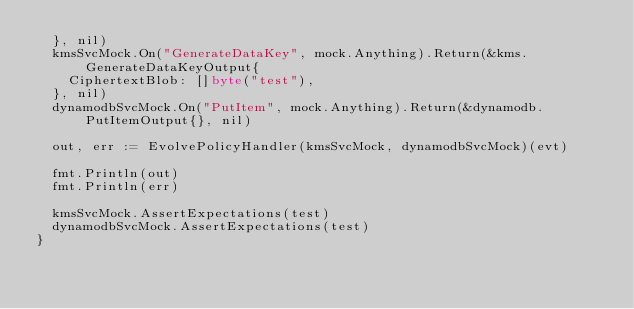Convert code to text. <code><loc_0><loc_0><loc_500><loc_500><_Go_>	}, nil)
	kmsSvcMock.On("GenerateDataKey", mock.Anything).Return(&kms.GenerateDataKeyOutput{
		CiphertextBlob: []byte("test"),
	}, nil)
	dynamodbSvcMock.On("PutItem", mock.Anything).Return(&dynamodb.PutItemOutput{}, nil)

	out, err := EvolvePolicyHandler(kmsSvcMock, dynamodbSvcMock)(evt)

	fmt.Println(out)
	fmt.Println(err)

	kmsSvcMock.AssertExpectations(test)
	dynamodbSvcMock.AssertExpectations(test)
}
</code> 